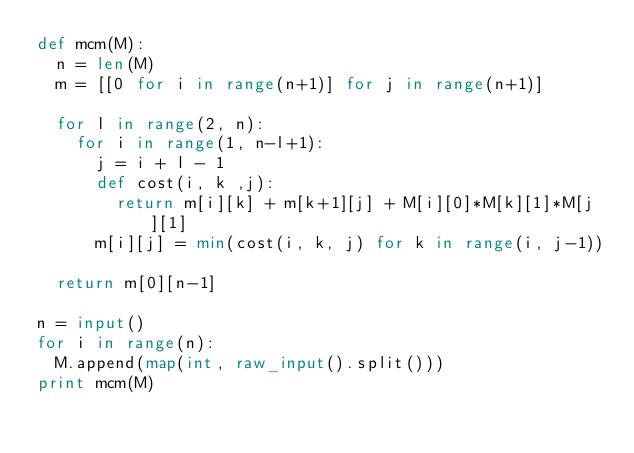Convert code to text. <code><loc_0><loc_0><loc_500><loc_500><_Python_>def mcm(M):
  n = len(M)
  m = [[0 for i in range(n+1)] for j in range(n+1)]
  
  for l in range(2, n):
    for i in range(1, n-l+1):
      j = i + l - 1
      def cost(i, k ,j):
        return m[i][k] + m[k+1][j] + M[i][0]*M[k][1]*M[j][1]
      m[i][j] = min(cost(i, k, j) for k in range(i, j-1))
  
  return m[0][n-1]

n = input()
for i in range(n):
  M.append(map(int, raw_input().split()))
print mcm(M)</code> 